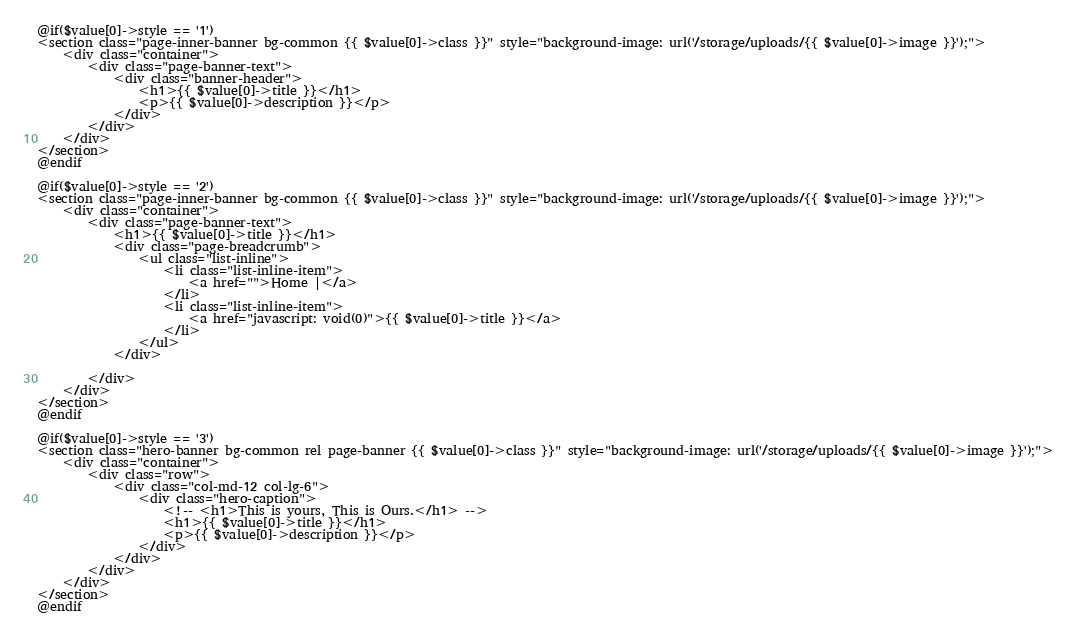<code> <loc_0><loc_0><loc_500><loc_500><_PHP_>@if($value[0]->style == '1')
<section class="page-inner-banner bg-common {{ $value[0]->class }}" style="background-image: url('/storage/uploads/{{ $value[0]->image }}');">
    <div class="container">
        <div class="page-banner-text">
            <div class="banner-header">
                <h1>{{ $value[0]->title }}</h1>
                <p>{{ $value[0]->description }}</p>
            </div>
        </div>
    </div>
</section>
@endif

@if($value[0]->style == '2')
<section class="page-inner-banner bg-common {{ $value[0]->class }}" style="background-image: url('/storage/uploads/{{ $value[0]->image }}');">
    <div class="container">
        <div class="page-banner-text">
            <h1>{{ $value[0]->title }}</h1>
            <div class="page-breadcrumb">
                <ul class="list-inline">
                    <li class="list-inline-item">
                        <a href="">Home |</a>
                    </li>
                    <li class="list-inline-item">
                        <a href="javascript: void(0)">{{ $value[0]->title }}</a>
                    </li>
                </ul>
            </div>

        </div>
    </div>
</section>
@endif

@if($value[0]->style == '3')
<section class="hero-banner bg-common rel page-banner {{ $value[0]->class }}" style="background-image: url('/storage/uploads/{{ $value[0]->image }}');">
    <div class="container">
        <div class="row">
            <div class="col-md-12 col-lg-6">
                <div class="hero-caption">
                    <!-- <h1>This is yours, This is Ours.</h1> -->
                    <h1>{{ $value[0]->title }}</h1>
                    <p>{{ $value[0]->description }}</p>
                </div>
            </div>
        </div>
    </div>
</section>
@endif</code> 